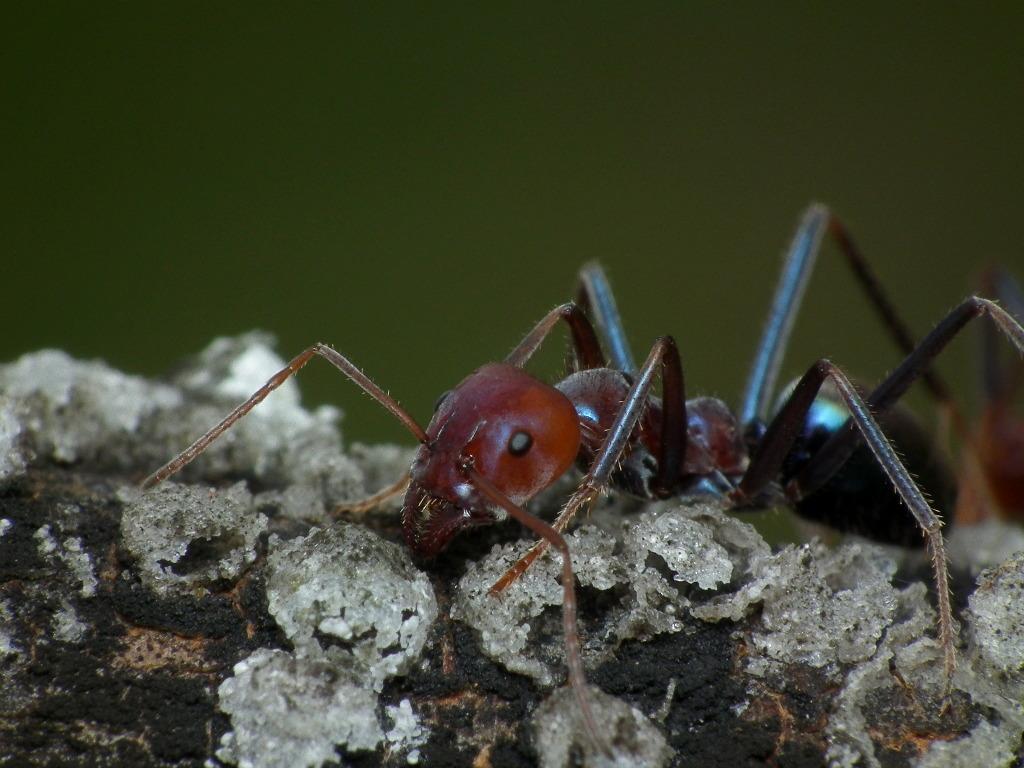Please provide a concise description of this image. In this picture I can see the insect on the wooden block. 